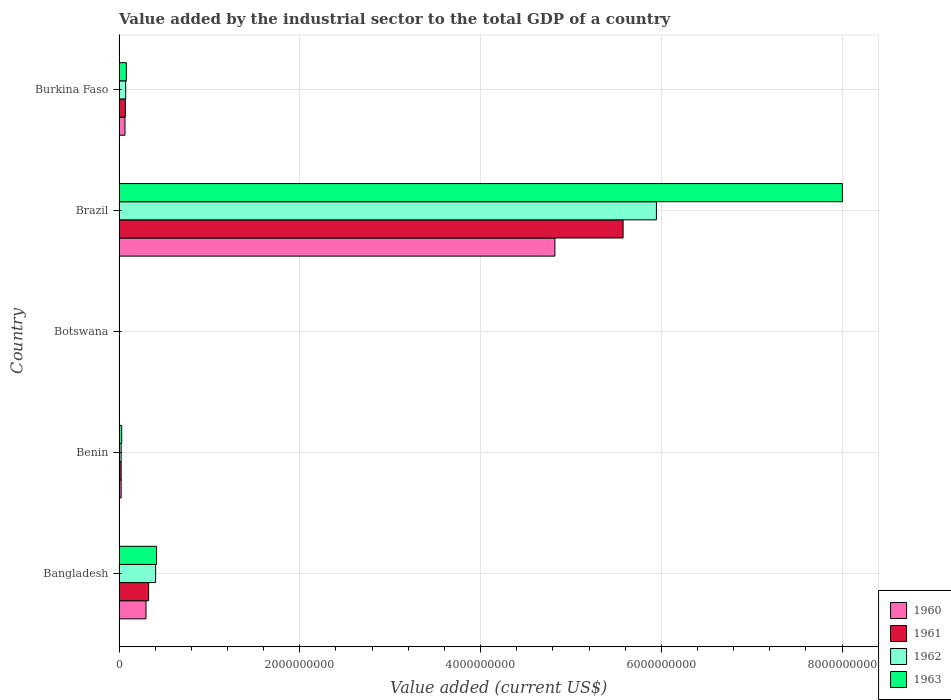How many different coloured bars are there?
Provide a short and direct response. 4. How many groups of bars are there?
Make the answer very short. 5. What is the label of the 1st group of bars from the top?
Offer a terse response. Burkina Faso. In how many cases, is the number of bars for a given country not equal to the number of legend labels?
Ensure brevity in your answer.  0. What is the value added by the industrial sector to the total GDP in 1962 in Benin?
Provide a succinct answer. 2.32e+07. Across all countries, what is the maximum value added by the industrial sector to the total GDP in 1961?
Offer a very short reply. 5.58e+09. Across all countries, what is the minimum value added by the industrial sector to the total GDP in 1961?
Make the answer very short. 4.05e+06. In which country was the value added by the industrial sector to the total GDP in 1962 minimum?
Offer a terse response. Botswana. What is the total value added by the industrial sector to the total GDP in 1963 in the graph?
Offer a very short reply. 8.53e+09. What is the difference between the value added by the industrial sector to the total GDP in 1961 in Bangladesh and that in Brazil?
Keep it short and to the point. -5.25e+09. What is the difference between the value added by the industrial sector to the total GDP in 1963 in Bangladesh and the value added by the industrial sector to the total GDP in 1960 in Brazil?
Keep it short and to the point. -4.41e+09. What is the average value added by the industrial sector to the total GDP in 1960 per country?
Your response must be concise. 1.04e+09. What is the difference between the value added by the industrial sector to the total GDP in 1963 and value added by the industrial sector to the total GDP in 1961 in Benin?
Keep it short and to the point. 6.00e+06. What is the ratio of the value added by the industrial sector to the total GDP in 1961 in Benin to that in Burkina Faso?
Ensure brevity in your answer.  0.33. What is the difference between the highest and the second highest value added by the industrial sector to the total GDP in 1963?
Your answer should be very brief. 7.59e+09. What is the difference between the highest and the lowest value added by the industrial sector to the total GDP in 1961?
Your answer should be very brief. 5.57e+09. What does the 4th bar from the bottom in Benin represents?
Provide a short and direct response. 1963. Is it the case that in every country, the sum of the value added by the industrial sector to the total GDP in 1962 and value added by the industrial sector to the total GDP in 1963 is greater than the value added by the industrial sector to the total GDP in 1960?
Give a very brief answer. Yes. Are all the bars in the graph horizontal?
Make the answer very short. Yes. Does the graph contain grids?
Your answer should be compact. Yes. How many legend labels are there?
Your answer should be very brief. 4. What is the title of the graph?
Make the answer very short. Value added by the industrial sector to the total GDP of a country. What is the label or title of the X-axis?
Offer a very short reply. Value added (current US$). What is the label or title of the Y-axis?
Offer a terse response. Country. What is the Value added (current US$) of 1960 in Bangladesh?
Provide a succinct answer. 2.98e+08. What is the Value added (current US$) in 1961 in Bangladesh?
Offer a very short reply. 3.27e+08. What is the Value added (current US$) in 1962 in Bangladesh?
Make the answer very short. 4.05e+08. What is the Value added (current US$) of 1963 in Bangladesh?
Make the answer very short. 4.15e+08. What is the Value added (current US$) in 1960 in Benin?
Give a very brief answer. 2.31e+07. What is the Value added (current US$) in 1961 in Benin?
Make the answer very short. 2.31e+07. What is the Value added (current US$) in 1962 in Benin?
Your answer should be compact. 2.32e+07. What is the Value added (current US$) of 1963 in Benin?
Your response must be concise. 2.91e+07. What is the Value added (current US$) in 1960 in Botswana?
Provide a succinct answer. 4.05e+06. What is the Value added (current US$) in 1961 in Botswana?
Keep it short and to the point. 4.05e+06. What is the Value added (current US$) in 1962 in Botswana?
Offer a very short reply. 4.05e+06. What is the Value added (current US$) of 1963 in Botswana?
Make the answer very short. 4.04e+06. What is the Value added (current US$) of 1960 in Brazil?
Offer a very short reply. 4.82e+09. What is the Value added (current US$) in 1961 in Brazil?
Your response must be concise. 5.58e+09. What is the Value added (current US$) in 1962 in Brazil?
Give a very brief answer. 5.95e+09. What is the Value added (current US$) in 1963 in Brazil?
Ensure brevity in your answer.  8.00e+09. What is the Value added (current US$) of 1960 in Burkina Faso?
Give a very brief answer. 6.58e+07. What is the Value added (current US$) in 1961 in Burkina Faso?
Your response must be concise. 6.97e+07. What is the Value added (current US$) of 1962 in Burkina Faso?
Provide a short and direct response. 7.35e+07. What is the Value added (current US$) of 1963 in Burkina Faso?
Offer a very short reply. 8.13e+07. Across all countries, what is the maximum Value added (current US$) of 1960?
Your answer should be very brief. 4.82e+09. Across all countries, what is the maximum Value added (current US$) in 1961?
Provide a short and direct response. 5.58e+09. Across all countries, what is the maximum Value added (current US$) of 1962?
Your answer should be compact. 5.95e+09. Across all countries, what is the maximum Value added (current US$) in 1963?
Keep it short and to the point. 8.00e+09. Across all countries, what is the minimum Value added (current US$) of 1960?
Your response must be concise. 4.05e+06. Across all countries, what is the minimum Value added (current US$) of 1961?
Give a very brief answer. 4.05e+06. Across all countries, what is the minimum Value added (current US$) of 1962?
Your answer should be compact. 4.05e+06. Across all countries, what is the minimum Value added (current US$) in 1963?
Keep it short and to the point. 4.04e+06. What is the total Value added (current US$) of 1960 in the graph?
Offer a very short reply. 5.21e+09. What is the total Value added (current US$) of 1961 in the graph?
Keep it short and to the point. 6.00e+09. What is the total Value added (current US$) of 1962 in the graph?
Provide a short and direct response. 6.45e+09. What is the total Value added (current US$) of 1963 in the graph?
Your answer should be compact. 8.53e+09. What is the difference between the Value added (current US$) of 1960 in Bangladesh and that in Benin?
Provide a succinct answer. 2.75e+08. What is the difference between the Value added (current US$) in 1961 in Bangladesh and that in Benin?
Provide a short and direct response. 3.04e+08. What is the difference between the Value added (current US$) in 1962 in Bangladesh and that in Benin?
Ensure brevity in your answer.  3.82e+08. What is the difference between the Value added (current US$) of 1963 in Bangladesh and that in Benin?
Your answer should be very brief. 3.86e+08. What is the difference between the Value added (current US$) of 1960 in Bangladesh and that in Botswana?
Ensure brevity in your answer.  2.94e+08. What is the difference between the Value added (current US$) in 1961 in Bangladesh and that in Botswana?
Give a very brief answer. 3.23e+08. What is the difference between the Value added (current US$) of 1962 in Bangladesh and that in Botswana?
Keep it short and to the point. 4.01e+08. What is the difference between the Value added (current US$) in 1963 in Bangladesh and that in Botswana?
Provide a succinct answer. 4.11e+08. What is the difference between the Value added (current US$) in 1960 in Bangladesh and that in Brazil?
Provide a short and direct response. -4.52e+09. What is the difference between the Value added (current US$) in 1961 in Bangladesh and that in Brazil?
Your answer should be very brief. -5.25e+09. What is the difference between the Value added (current US$) in 1962 in Bangladesh and that in Brazil?
Offer a very short reply. -5.54e+09. What is the difference between the Value added (current US$) of 1963 in Bangladesh and that in Brazil?
Make the answer very short. -7.59e+09. What is the difference between the Value added (current US$) in 1960 in Bangladesh and that in Burkina Faso?
Provide a short and direct response. 2.32e+08. What is the difference between the Value added (current US$) in 1961 in Bangladesh and that in Burkina Faso?
Your response must be concise. 2.58e+08. What is the difference between the Value added (current US$) of 1962 in Bangladesh and that in Burkina Faso?
Your answer should be very brief. 3.31e+08. What is the difference between the Value added (current US$) in 1963 in Bangladesh and that in Burkina Faso?
Offer a terse response. 3.34e+08. What is the difference between the Value added (current US$) in 1960 in Benin and that in Botswana?
Provide a short and direct response. 1.91e+07. What is the difference between the Value added (current US$) of 1961 in Benin and that in Botswana?
Offer a very short reply. 1.91e+07. What is the difference between the Value added (current US$) of 1962 in Benin and that in Botswana?
Offer a terse response. 1.91e+07. What is the difference between the Value added (current US$) of 1963 in Benin and that in Botswana?
Your response must be concise. 2.51e+07. What is the difference between the Value added (current US$) of 1960 in Benin and that in Brazil?
Give a very brief answer. -4.80e+09. What is the difference between the Value added (current US$) in 1961 in Benin and that in Brazil?
Provide a succinct answer. -5.55e+09. What is the difference between the Value added (current US$) in 1962 in Benin and that in Brazil?
Make the answer very short. -5.92e+09. What is the difference between the Value added (current US$) of 1963 in Benin and that in Brazil?
Make the answer very short. -7.97e+09. What is the difference between the Value added (current US$) of 1960 in Benin and that in Burkina Faso?
Keep it short and to the point. -4.27e+07. What is the difference between the Value added (current US$) in 1961 in Benin and that in Burkina Faso?
Give a very brief answer. -4.66e+07. What is the difference between the Value added (current US$) in 1962 in Benin and that in Burkina Faso?
Offer a terse response. -5.04e+07. What is the difference between the Value added (current US$) in 1963 in Benin and that in Burkina Faso?
Make the answer very short. -5.21e+07. What is the difference between the Value added (current US$) of 1960 in Botswana and that in Brazil?
Your answer should be very brief. -4.82e+09. What is the difference between the Value added (current US$) of 1961 in Botswana and that in Brazil?
Offer a terse response. -5.57e+09. What is the difference between the Value added (current US$) in 1962 in Botswana and that in Brazil?
Make the answer very short. -5.94e+09. What is the difference between the Value added (current US$) of 1963 in Botswana and that in Brazil?
Make the answer very short. -8.00e+09. What is the difference between the Value added (current US$) in 1960 in Botswana and that in Burkina Faso?
Offer a very short reply. -6.17e+07. What is the difference between the Value added (current US$) of 1961 in Botswana and that in Burkina Faso?
Make the answer very short. -6.56e+07. What is the difference between the Value added (current US$) in 1962 in Botswana and that in Burkina Faso?
Your answer should be compact. -6.95e+07. What is the difference between the Value added (current US$) in 1963 in Botswana and that in Burkina Faso?
Provide a succinct answer. -7.72e+07. What is the difference between the Value added (current US$) of 1960 in Brazil and that in Burkina Faso?
Provide a short and direct response. 4.76e+09. What is the difference between the Value added (current US$) in 1961 in Brazil and that in Burkina Faso?
Your answer should be very brief. 5.51e+09. What is the difference between the Value added (current US$) of 1962 in Brazil and that in Burkina Faso?
Ensure brevity in your answer.  5.87e+09. What is the difference between the Value added (current US$) of 1963 in Brazil and that in Burkina Faso?
Provide a short and direct response. 7.92e+09. What is the difference between the Value added (current US$) in 1960 in Bangladesh and the Value added (current US$) in 1961 in Benin?
Your answer should be compact. 2.75e+08. What is the difference between the Value added (current US$) of 1960 in Bangladesh and the Value added (current US$) of 1962 in Benin?
Provide a short and direct response. 2.75e+08. What is the difference between the Value added (current US$) of 1960 in Bangladesh and the Value added (current US$) of 1963 in Benin?
Provide a succinct answer. 2.69e+08. What is the difference between the Value added (current US$) of 1961 in Bangladesh and the Value added (current US$) of 1962 in Benin?
Offer a very short reply. 3.04e+08. What is the difference between the Value added (current US$) in 1961 in Bangladesh and the Value added (current US$) in 1963 in Benin?
Your answer should be very brief. 2.98e+08. What is the difference between the Value added (current US$) in 1962 in Bangladesh and the Value added (current US$) in 1963 in Benin?
Offer a very short reply. 3.76e+08. What is the difference between the Value added (current US$) of 1960 in Bangladesh and the Value added (current US$) of 1961 in Botswana?
Your answer should be compact. 2.94e+08. What is the difference between the Value added (current US$) in 1960 in Bangladesh and the Value added (current US$) in 1962 in Botswana?
Your response must be concise. 2.94e+08. What is the difference between the Value added (current US$) in 1960 in Bangladesh and the Value added (current US$) in 1963 in Botswana?
Your response must be concise. 2.94e+08. What is the difference between the Value added (current US$) of 1961 in Bangladesh and the Value added (current US$) of 1962 in Botswana?
Your response must be concise. 3.23e+08. What is the difference between the Value added (current US$) in 1961 in Bangladesh and the Value added (current US$) in 1963 in Botswana?
Offer a terse response. 3.23e+08. What is the difference between the Value added (current US$) of 1962 in Bangladesh and the Value added (current US$) of 1963 in Botswana?
Provide a succinct answer. 4.01e+08. What is the difference between the Value added (current US$) of 1960 in Bangladesh and the Value added (current US$) of 1961 in Brazil?
Offer a very short reply. -5.28e+09. What is the difference between the Value added (current US$) in 1960 in Bangladesh and the Value added (current US$) in 1962 in Brazil?
Provide a short and direct response. -5.65e+09. What is the difference between the Value added (current US$) in 1960 in Bangladesh and the Value added (current US$) in 1963 in Brazil?
Offer a terse response. -7.71e+09. What is the difference between the Value added (current US$) of 1961 in Bangladesh and the Value added (current US$) of 1962 in Brazil?
Keep it short and to the point. -5.62e+09. What is the difference between the Value added (current US$) of 1961 in Bangladesh and the Value added (current US$) of 1963 in Brazil?
Keep it short and to the point. -7.68e+09. What is the difference between the Value added (current US$) in 1962 in Bangladesh and the Value added (current US$) in 1963 in Brazil?
Provide a succinct answer. -7.60e+09. What is the difference between the Value added (current US$) of 1960 in Bangladesh and the Value added (current US$) of 1961 in Burkina Faso?
Offer a terse response. 2.28e+08. What is the difference between the Value added (current US$) in 1960 in Bangladesh and the Value added (current US$) in 1962 in Burkina Faso?
Ensure brevity in your answer.  2.25e+08. What is the difference between the Value added (current US$) in 1960 in Bangladesh and the Value added (current US$) in 1963 in Burkina Faso?
Provide a succinct answer. 2.17e+08. What is the difference between the Value added (current US$) of 1961 in Bangladesh and the Value added (current US$) of 1962 in Burkina Faso?
Your answer should be compact. 2.54e+08. What is the difference between the Value added (current US$) of 1961 in Bangladesh and the Value added (current US$) of 1963 in Burkina Faso?
Ensure brevity in your answer.  2.46e+08. What is the difference between the Value added (current US$) in 1962 in Bangladesh and the Value added (current US$) in 1963 in Burkina Faso?
Your answer should be very brief. 3.23e+08. What is the difference between the Value added (current US$) in 1960 in Benin and the Value added (current US$) in 1961 in Botswana?
Offer a terse response. 1.91e+07. What is the difference between the Value added (current US$) in 1960 in Benin and the Value added (current US$) in 1962 in Botswana?
Give a very brief answer. 1.91e+07. What is the difference between the Value added (current US$) in 1960 in Benin and the Value added (current US$) in 1963 in Botswana?
Your answer should be very brief. 1.91e+07. What is the difference between the Value added (current US$) of 1961 in Benin and the Value added (current US$) of 1962 in Botswana?
Your response must be concise. 1.91e+07. What is the difference between the Value added (current US$) in 1961 in Benin and the Value added (current US$) in 1963 in Botswana?
Provide a short and direct response. 1.91e+07. What is the difference between the Value added (current US$) of 1962 in Benin and the Value added (current US$) of 1963 in Botswana?
Provide a succinct answer. 1.91e+07. What is the difference between the Value added (current US$) of 1960 in Benin and the Value added (current US$) of 1961 in Brazil?
Make the answer very short. -5.55e+09. What is the difference between the Value added (current US$) of 1960 in Benin and the Value added (current US$) of 1962 in Brazil?
Offer a terse response. -5.92e+09. What is the difference between the Value added (current US$) of 1960 in Benin and the Value added (current US$) of 1963 in Brazil?
Your answer should be very brief. -7.98e+09. What is the difference between the Value added (current US$) of 1961 in Benin and the Value added (current US$) of 1962 in Brazil?
Provide a succinct answer. -5.92e+09. What is the difference between the Value added (current US$) of 1961 in Benin and the Value added (current US$) of 1963 in Brazil?
Provide a short and direct response. -7.98e+09. What is the difference between the Value added (current US$) of 1962 in Benin and the Value added (current US$) of 1963 in Brazil?
Keep it short and to the point. -7.98e+09. What is the difference between the Value added (current US$) of 1960 in Benin and the Value added (current US$) of 1961 in Burkina Faso?
Your answer should be very brief. -4.65e+07. What is the difference between the Value added (current US$) of 1960 in Benin and the Value added (current US$) of 1962 in Burkina Faso?
Ensure brevity in your answer.  -5.04e+07. What is the difference between the Value added (current US$) of 1960 in Benin and the Value added (current US$) of 1963 in Burkina Faso?
Offer a terse response. -5.81e+07. What is the difference between the Value added (current US$) in 1961 in Benin and the Value added (current US$) in 1962 in Burkina Faso?
Your answer should be compact. -5.04e+07. What is the difference between the Value added (current US$) of 1961 in Benin and the Value added (current US$) of 1963 in Burkina Faso?
Ensure brevity in your answer.  -5.81e+07. What is the difference between the Value added (current US$) of 1962 in Benin and the Value added (current US$) of 1963 in Burkina Faso?
Make the answer very short. -5.81e+07. What is the difference between the Value added (current US$) in 1960 in Botswana and the Value added (current US$) in 1961 in Brazil?
Offer a terse response. -5.57e+09. What is the difference between the Value added (current US$) in 1960 in Botswana and the Value added (current US$) in 1962 in Brazil?
Provide a succinct answer. -5.94e+09. What is the difference between the Value added (current US$) of 1960 in Botswana and the Value added (current US$) of 1963 in Brazil?
Offer a terse response. -8.00e+09. What is the difference between the Value added (current US$) of 1961 in Botswana and the Value added (current US$) of 1962 in Brazil?
Provide a short and direct response. -5.94e+09. What is the difference between the Value added (current US$) of 1961 in Botswana and the Value added (current US$) of 1963 in Brazil?
Offer a terse response. -8.00e+09. What is the difference between the Value added (current US$) of 1962 in Botswana and the Value added (current US$) of 1963 in Brazil?
Provide a short and direct response. -8.00e+09. What is the difference between the Value added (current US$) of 1960 in Botswana and the Value added (current US$) of 1961 in Burkina Faso?
Your answer should be compact. -6.56e+07. What is the difference between the Value added (current US$) of 1960 in Botswana and the Value added (current US$) of 1962 in Burkina Faso?
Ensure brevity in your answer.  -6.95e+07. What is the difference between the Value added (current US$) of 1960 in Botswana and the Value added (current US$) of 1963 in Burkina Faso?
Ensure brevity in your answer.  -7.72e+07. What is the difference between the Value added (current US$) in 1961 in Botswana and the Value added (current US$) in 1962 in Burkina Faso?
Offer a very short reply. -6.95e+07. What is the difference between the Value added (current US$) of 1961 in Botswana and the Value added (current US$) of 1963 in Burkina Faso?
Offer a terse response. -7.72e+07. What is the difference between the Value added (current US$) of 1962 in Botswana and the Value added (current US$) of 1963 in Burkina Faso?
Make the answer very short. -7.72e+07. What is the difference between the Value added (current US$) in 1960 in Brazil and the Value added (current US$) in 1961 in Burkina Faso?
Your response must be concise. 4.75e+09. What is the difference between the Value added (current US$) of 1960 in Brazil and the Value added (current US$) of 1962 in Burkina Faso?
Provide a short and direct response. 4.75e+09. What is the difference between the Value added (current US$) of 1960 in Brazil and the Value added (current US$) of 1963 in Burkina Faso?
Make the answer very short. 4.74e+09. What is the difference between the Value added (current US$) of 1961 in Brazil and the Value added (current US$) of 1962 in Burkina Faso?
Your response must be concise. 5.50e+09. What is the difference between the Value added (current US$) in 1961 in Brazil and the Value added (current US$) in 1963 in Burkina Faso?
Ensure brevity in your answer.  5.50e+09. What is the difference between the Value added (current US$) in 1962 in Brazil and the Value added (current US$) in 1963 in Burkina Faso?
Your answer should be compact. 5.86e+09. What is the average Value added (current US$) in 1960 per country?
Provide a succinct answer. 1.04e+09. What is the average Value added (current US$) in 1961 per country?
Give a very brief answer. 1.20e+09. What is the average Value added (current US$) of 1962 per country?
Provide a short and direct response. 1.29e+09. What is the average Value added (current US$) in 1963 per country?
Provide a succinct answer. 1.71e+09. What is the difference between the Value added (current US$) in 1960 and Value added (current US$) in 1961 in Bangladesh?
Your answer should be very brief. -2.92e+07. What is the difference between the Value added (current US$) in 1960 and Value added (current US$) in 1962 in Bangladesh?
Keep it short and to the point. -1.07e+08. What is the difference between the Value added (current US$) in 1960 and Value added (current US$) in 1963 in Bangladesh?
Provide a short and direct response. -1.17e+08. What is the difference between the Value added (current US$) in 1961 and Value added (current US$) in 1962 in Bangladesh?
Offer a terse response. -7.74e+07. What is the difference between the Value added (current US$) of 1961 and Value added (current US$) of 1963 in Bangladesh?
Give a very brief answer. -8.78e+07. What is the difference between the Value added (current US$) in 1962 and Value added (current US$) in 1963 in Bangladesh?
Keep it short and to the point. -1.05e+07. What is the difference between the Value added (current US$) in 1960 and Value added (current US$) in 1961 in Benin?
Give a very brief answer. 6130.83. What is the difference between the Value added (current US$) in 1960 and Value added (current US$) in 1962 in Benin?
Your response must be concise. -1.71e+04. What is the difference between the Value added (current US$) of 1960 and Value added (current US$) of 1963 in Benin?
Offer a very short reply. -5.99e+06. What is the difference between the Value added (current US$) of 1961 and Value added (current US$) of 1962 in Benin?
Your answer should be very brief. -2.32e+04. What is the difference between the Value added (current US$) in 1961 and Value added (current US$) in 1963 in Benin?
Your response must be concise. -6.00e+06. What is the difference between the Value added (current US$) in 1962 and Value added (current US$) in 1963 in Benin?
Make the answer very short. -5.97e+06. What is the difference between the Value added (current US$) of 1960 and Value added (current US$) of 1961 in Botswana?
Offer a very short reply. 7791.27. What is the difference between the Value added (current US$) in 1960 and Value added (current US$) in 1962 in Botswana?
Your answer should be compact. -314.81. What is the difference between the Value added (current US$) in 1960 and Value added (current US$) in 1963 in Botswana?
Your answer should be very brief. 1.11e+04. What is the difference between the Value added (current US$) of 1961 and Value added (current US$) of 1962 in Botswana?
Offer a terse response. -8106.08. What is the difference between the Value added (current US$) of 1961 and Value added (current US$) of 1963 in Botswana?
Give a very brief answer. 3353.04. What is the difference between the Value added (current US$) in 1962 and Value added (current US$) in 1963 in Botswana?
Your response must be concise. 1.15e+04. What is the difference between the Value added (current US$) in 1960 and Value added (current US$) in 1961 in Brazil?
Give a very brief answer. -7.55e+08. What is the difference between the Value added (current US$) in 1960 and Value added (current US$) in 1962 in Brazil?
Your answer should be compact. -1.12e+09. What is the difference between the Value added (current US$) in 1960 and Value added (current US$) in 1963 in Brazil?
Offer a terse response. -3.18e+09. What is the difference between the Value added (current US$) in 1961 and Value added (current US$) in 1962 in Brazil?
Your answer should be very brief. -3.69e+08. What is the difference between the Value added (current US$) of 1961 and Value added (current US$) of 1963 in Brazil?
Provide a short and direct response. -2.43e+09. What is the difference between the Value added (current US$) in 1962 and Value added (current US$) in 1963 in Brazil?
Provide a succinct answer. -2.06e+09. What is the difference between the Value added (current US$) in 1960 and Value added (current US$) in 1961 in Burkina Faso?
Your answer should be compact. -3.88e+06. What is the difference between the Value added (current US$) in 1960 and Value added (current US$) in 1962 in Burkina Faso?
Provide a short and direct response. -7.71e+06. What is the difference between the Value added (current US$) of 1960 and Value added (current US$) of 1963 in Burkina Faso?
Your answer should be very brief. -1.55e+07. What is the difference between the Value added (current US$) of 1961 and Value added (current US$) of 1962 in Burkina Faso?
Offer a terse response. -3.83e+06. What is the difference between the Value added (current US$) of 1961 and Value added (current US$) of 1963 in Burkina Faso?
Provide a succinct answer. -1.16e+07. What is the difference between the Value added (current US$) in 1962 and Value added (current US$) in 1963 in Burkina Faso?
Offer a very short reply. -7.75e+06. What is the ratio of the Value added (current US$) in 1960 in Bangladesh to that in Benin?
Your response must be concise. 12.89. What is the ratio of the Value added (current US$) in 1961 in Bangladesh to that in Benin?
Offer a terse response. 14.15. What is the ratio of the Value added (current US$) of 1962 in Bangladesh to that in Benin?
Your answer should be compact. 17.48. What is the ratio of the Value added (current US$) in 1963 in Bangladesh to that in Benin?
Give a very brief answer. 14.26. What is the ratio of the Value added (current US$) in 1960 in Bangladesh to that in Botswana?
Keep it short and to the point. 73.54. What is the ratio of the Value added (current US$) in 1961 in Bangladesh to that in Botswana?
Provide a succinct answer. 80.89. What is the ratio of the Value added (current US$) of 1962 in Bangladesh to that in Botswana?
Your answer should be very brief. 99.81. What is the ratio of the Value added (current US$) of 1963 in Bangladesh to that in Botswana?
Your answer should be very brief. 102.69. What is the ratio of the Value added (current US$) in 1960 in Bangladesh to that in Brazil?
Provide a succinct answer. 0.06. What is the ratio of the Value added (current US$) in 1961 in Bangladesh to that in Brazil?
Your answer should be very brief. 0.06. What is the ratio of the Value added (current US$) of 1962 in Bangladesh to that in Brazil?
Offer a terse response. 0.07. What is the ratio of the Value added (current US$) of 1963 in Bangladesh to that in Brazil?
Keep it short and to the point. 0.05. What is the ratio of the Value added (current US$) in 1960 in Bangladesh to that in Burkina Faso?
Give a very brief answer. 4.53. What is the ratio of the Value added (current US$) of 1961 in Bangladesh to that in Burkina Faso?
Your response must be concise. 4.7. What is the ratio of the Value added (current US$) of 1962 in Bangladesh to that in Burkina Faso?
Make the answer very short. 5.5. What is the ratio of the Value added (current US$) of 1963 in Bangladesh to that in Burkina Faso?
Provide a succinct answer. 5.11. What is the ratio of the Value added (current US$) in 1960 in Benin to that in Botswana?
Provide a short and direct response. 5.71. What is the ratio of the Value added (current US$) in 1961 in Benin to that in Botswana?
Provide a succinct answer. 5.72. What is the ratio of the Value added (current US$) of 1962 in Benin to that in Botswana?
Offer a very short reply. 5.71. What is the ratio of the Value added (current US$) in 1963 in Benin to that in Botswana?
Offer a very short reply. 7.2. What is the ratio of the Value added (current US$) of 1960 in Benin to that in Brazil?
Your response must be concise. 0. What is the ratio of the Value added (current US$) in 1961 in Benin to that in Brazil?
Your answer should be very brief. 0. What is the ratio of the Value added (current US$) in 1962 in Benin to that in Brazil?
Keep it short and to the point. 0. What is the ratio of the Value added (current US$) of 1963 in Benin to that in Brazil?
Offer a very short reply. 0. What is the ratio of the Value added (current US$) of 1960 in Benin to that in Burkina Faso?
Offer a terse response. 0.35. What is the ratio of the Value added (current US$) of 1961 in Benin to that in Burkina Faso?
Offer a very short reply. 0.33. What is the ratio of the Value added (current US$) of 1962 in Benin to that in Burkina Faso?
Your answer should be very brief. 0.31. What is the ratio of the Value added (current US$) in 1963 in Benin to that in Burkina Faso?
Give a very brief answer. 0.36. What is the ratio of the Value added (current US$) in 1960 in Botswana to that in Brazil?
Ensure brevity in your answer.  0. What is the ratio of the Value added (current US$) of 1961 in Botswana to that in Brazil?
Your answer should be very brief. 0. What is the ratio of the Value added (current US$) in 1962 in Botswana to that in Brazil?
Your answer should be compact. 0. What is the ratio of the Value added (current US$) of 1960 in Botswana to that in Burkina Faso?
Keep it short and to the point. 0.06. What is the ratio of the Value added (current US$) in 1961 in Botswana to that in Burkina Faso?
Your answer should be compact. 0.06. What is the ratio of the Value added (current US$) of 1962 in Botswana to that in Burkina Faso?
Your answer should be compact. 0.06. What is the ratio of the Value added (current US$) of 1963 in Botswana to that in Burkina Faso?
Offer a very short reply. 0.05. What is the ratio of the Value added (current US$) of 1960 in Brazil to that in Burkina Faso?
Provide a short and direct response. 73.29. What is the ratio of the Value added (current US$) in 1961 in Brazil to that in Burkina Faso?
Provide a short and direct response. 80.04. What is the ratio of the Value added (current US$) in 1962 in Brazil to that in Burkina Faso?
Your answer should be compact. 80.89. What is the ratio of the Value added (current US$) in 1963 in Brazil to that in Burkina Faso?
Ensure brevity in your answer.  98.49. What is the difference between the highest and the second highest Value added (current US$) of 1960?
Offer a very short reply. 4.52e+09. What is the difference between the highest and the second highest Value added (current US$) in 1961?
Provide a succinct answer. 5.25e+09. What is the difference between the highest and the second highest Value added (current US$) in 1962?
Give a very brief answer. 5.54e+09. What is the difference between the highest and the second highest Value added (current US$) in 1963?
Ensure brevity in your answer.  7.59e+09. What is the difference between the highest and the lowest Value added (current US$) in 1960?
Your answer should be compact. 4.82e+09. What is the difference between the highest and the lowest Value added (current US$) of 1961?
Your answer should be compact. 5.57e+09. What is the difference between the highest and the lowest Value added (current US$) of 1962?
Your response must be concise. 5.94e+09. What is the difference between the highest and the lowest Value added (current US$) in 1963?
Provide a short and direct response. 8.00e+09. 